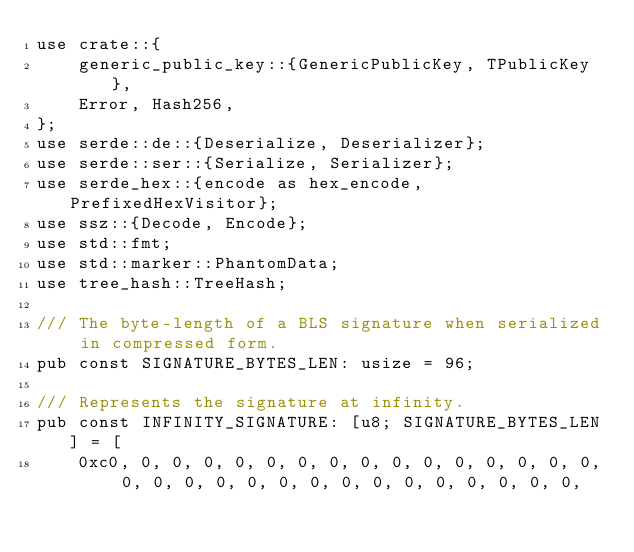Convert code to text. <code><loc_0><loc_0><loc_500><loc_500><_Rust_>use crate::{
    generic_public_key::{GenericPublicKey, TPublicKey},
    Error, Hash256,
};
use serde::de::{Deserialize, Deserializer};
use serde::ser::{Serialize, Serializer};
use serde_hex::{encode as hex_encode, PrefixedHexVisitor};
use ssz::{Decode, Encode};
use std::fmt;
use std::marker::PhantomData;
use tree_hash::TreeHash;

/// The byte-length of a BLS signature when serialized in compressed form.
pub const SIGNATURE_BYTES_LEN: usize = 96;

/// Represents the signature at infinity.
pub const INFINITY_SIGNATURE: [u8; SIGNATURE_BYTES_LEN] = [
    0xc0, 0, 0, 0, 0, 0, 0, 0, 0, 0, 0, 0, 0, 0, 0, 0, 0, 0, 0, 0, 0, 0, 0, 0, 0, 0, 0, 0, 0, 0, 0,</code> 